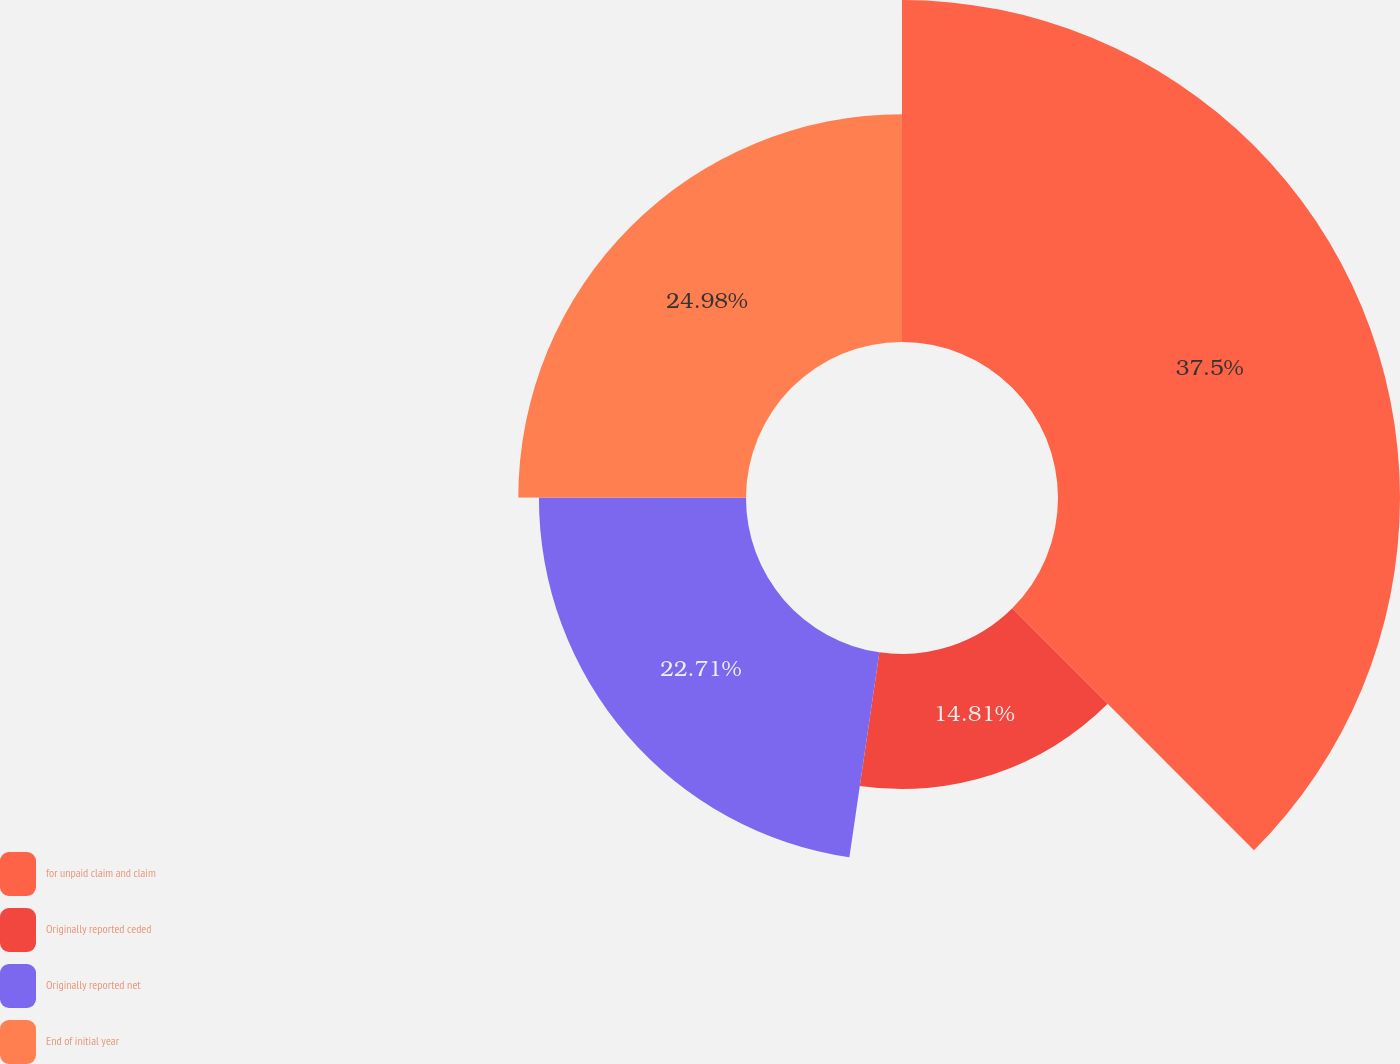<chart> <loc_0><loc_0><loc_500><loc_500><pie_chart><fcel>for unpaid claim and claim<fcel>Originally reported ceded<fcel>Originally reported net<fcel>End of initial year<nl><fcel>37.51%<fcel>14.81%<fcel>22.71%<fcel>24.98%<nl></chart> 